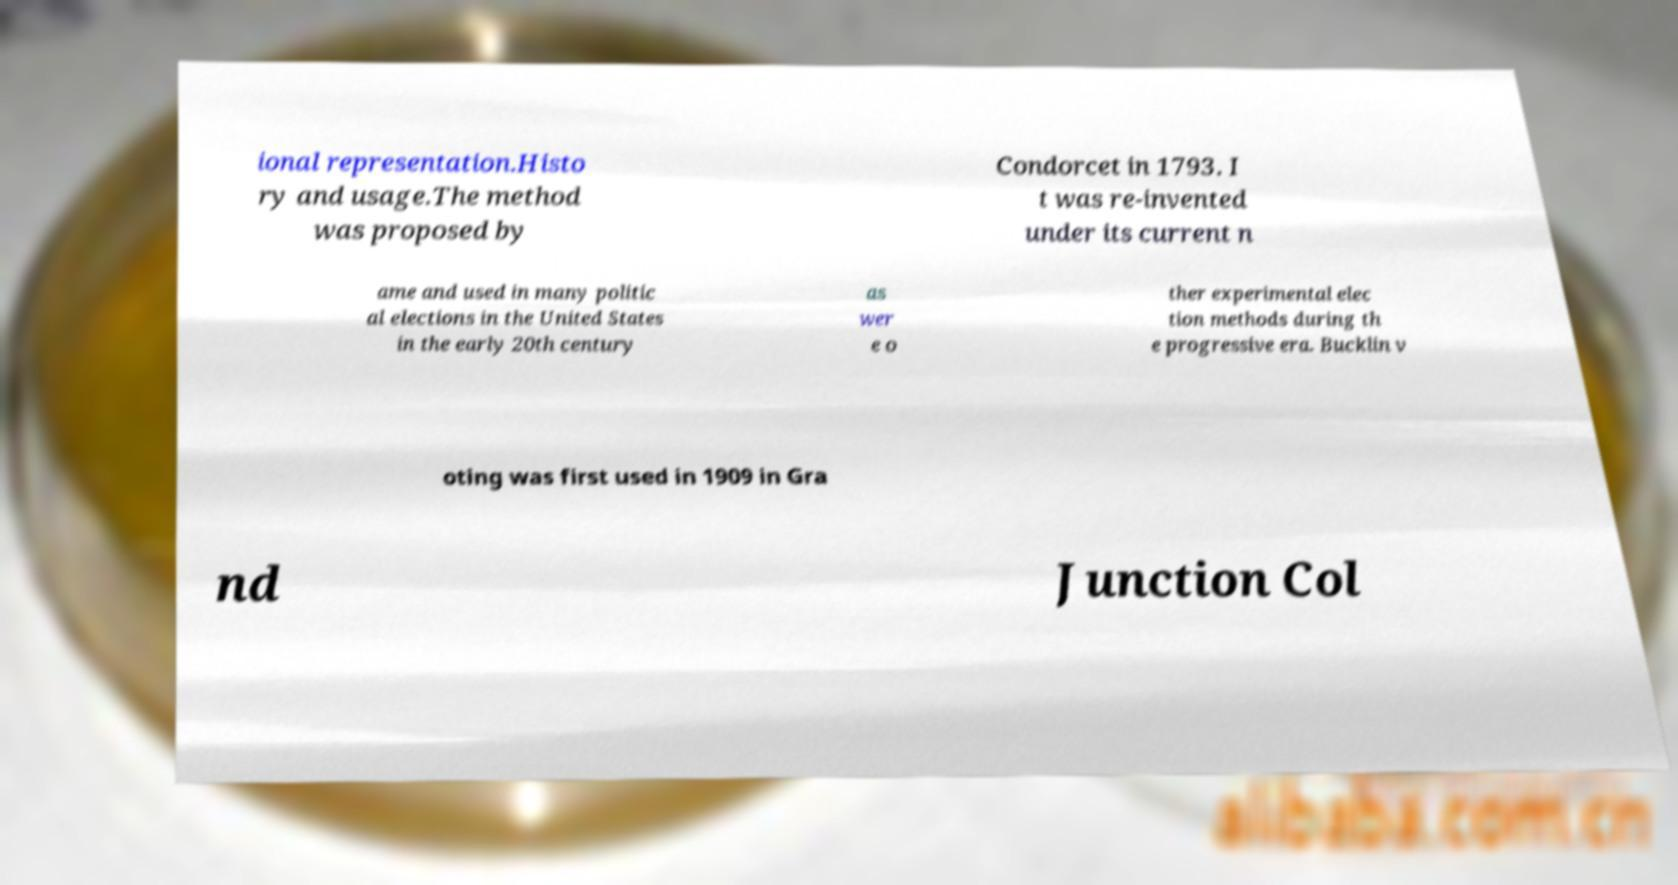Can you accurately transcribe the text from the provided image for me? ional representation.Histo ry and usage.The method was proposed by Condorcet in 1793. I t was re-invented under its current n ame and used in many politic al elections in the United States in the early 20th century as wer e o ther experimental elec tion methods during th e progressive era. Bucklin v oting was first used in 1909 in Gra nd Junction Col 